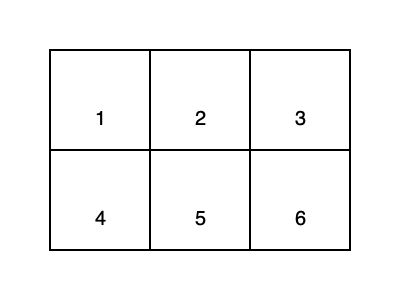In your efforts to develop spatial reasoning skills for inmate rehabilitation programs, you present this 2D net. When folded along the lines, which 3D shape is formed? To determine the 3D shape formed by folding this net, let's follow these steps:

1. Identify the shape of each face:
   - All faces are rectangles.
   - There are 6 rectangular faces in total.

2. Analyze the arrangement:
   - The net shows a long strip of 4 rectangles (faces 1, 2, 3, and 6).
   - Two additional rectangles (faces 4 and 5) are attached to the middle section.

3. Visualize the folding process:
   - Faces 1 and 3 will form opposite sides.
   - Faces 4 and 6 will form another pair of opposite sides.
   - Faces 2 and 5 will complete the remaining pair of opposite sides.

4. Recognize the resulting shape:
   - A shape with 6 rectangular faces, arranged in 3 pairs of parallel faces.
   - Each face is perpendicular to its adjacent faces.
   - All angles are 90 degrees.

These characteristics uniquely define a rectangular prism, also known as a cuboid.

In the context of inmate rehabilitation, understanding this spatial transformation can help develop problem-solving skills and improve abstract thinking, which are valuable for personal growth and future employment opportunities.
Answer: Rectangular prism (cuboid) 